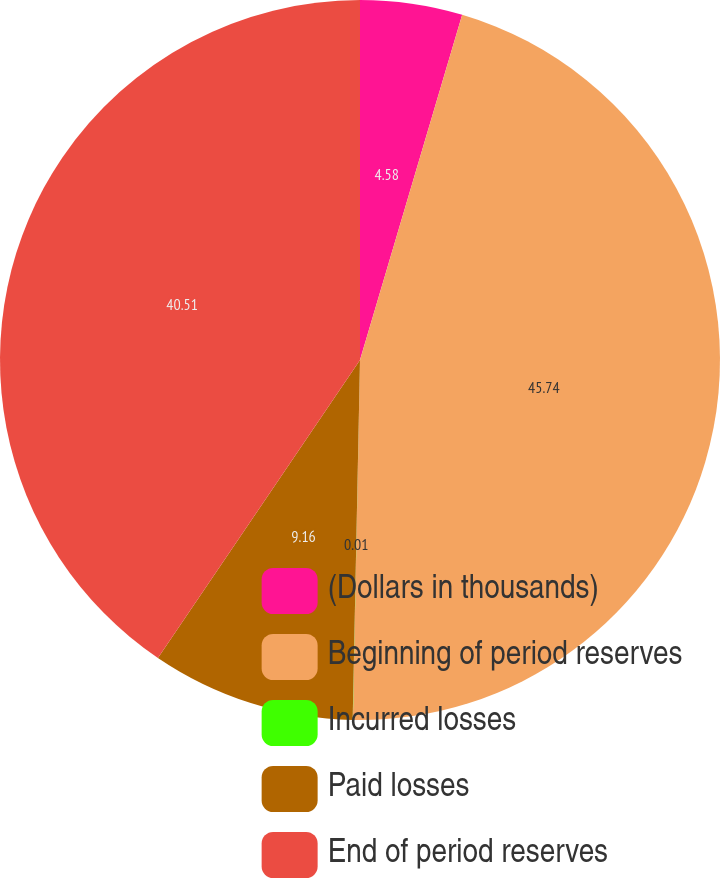Convert chart. <chart><loc_0><loc_0><loc_500><loc_500><pie_chart><fcel>(Dollars in thousands)<fcel>Beginning of period reserves<fcel>Incurred losses<fcel>Paid losses<fcel>End of period reserves<nl><fcel>4.58%<fcel>45.73%<fcel>0.01%<fcel>9.16%<fcel>40.51%<nl></chart> 